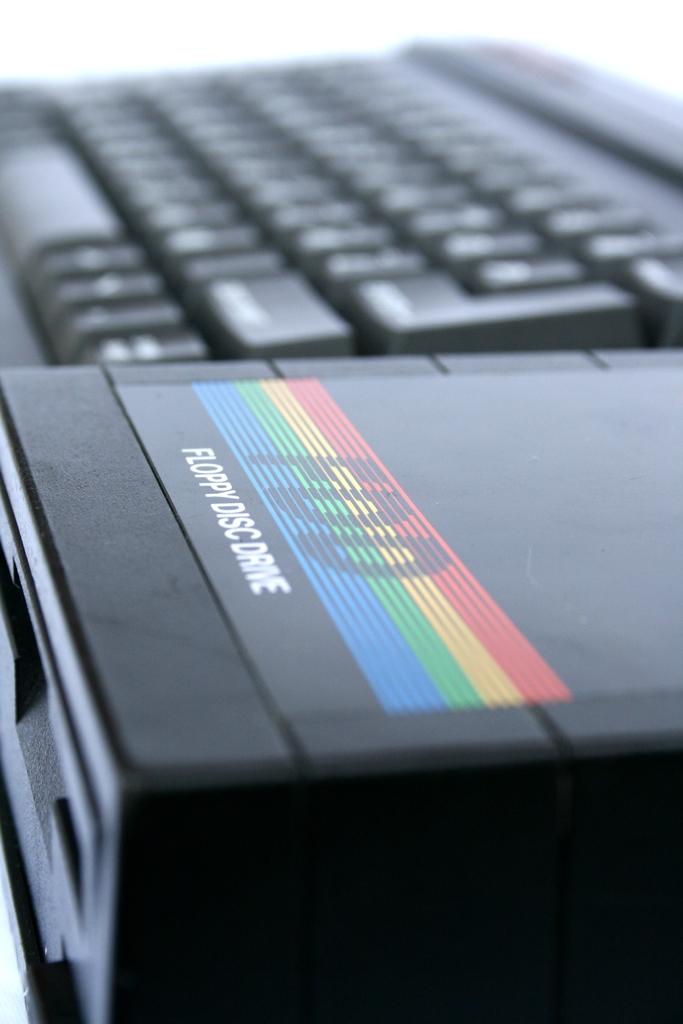Whats the box holding?
Your answer should be very brief. Floppy disc. What kind of drive is this?
Provide a succinct answer. Floppy disc. 